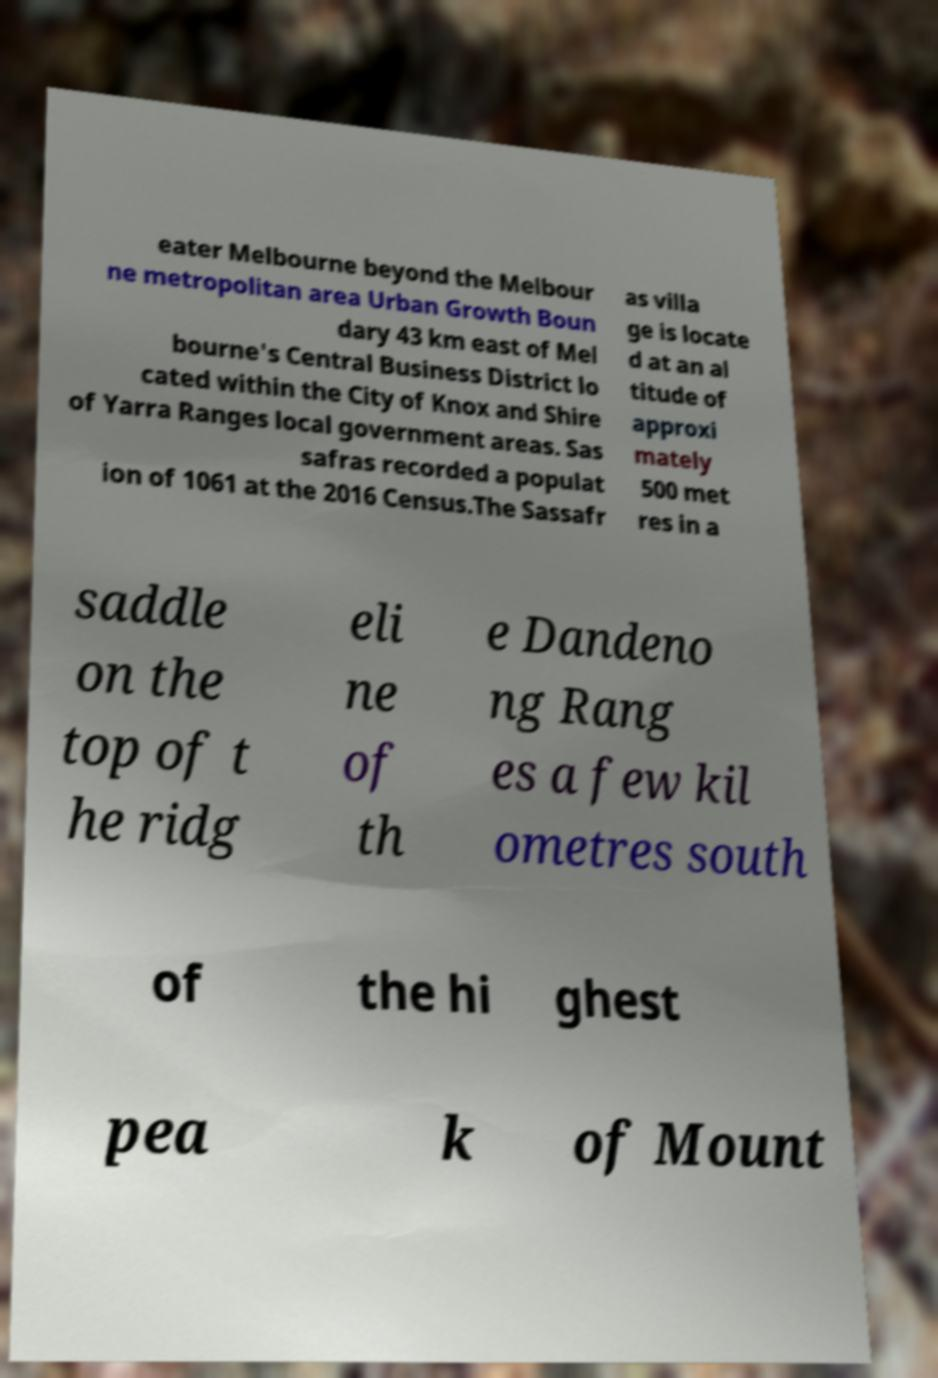Please read and relay the text visible in this image. What does it say? eater Melbourne beyond the Melbour ne metropolitan area Urban Growth Boun dary 43 km east of Mel bourne's Central Business District lo cated within the City of Knox and Shire of Yarra Ranges local government areas. Sas safras recorded a populat ion of 1061 at the 2016 Census.The Sassafr as villa ge is locate d at an al titude of approxi mately 500 met res in a saddle on the top of t he ridg eli ne of th e Dandeno ng Rang es a few kil ometres south of the hi ghest pea k of Mount 